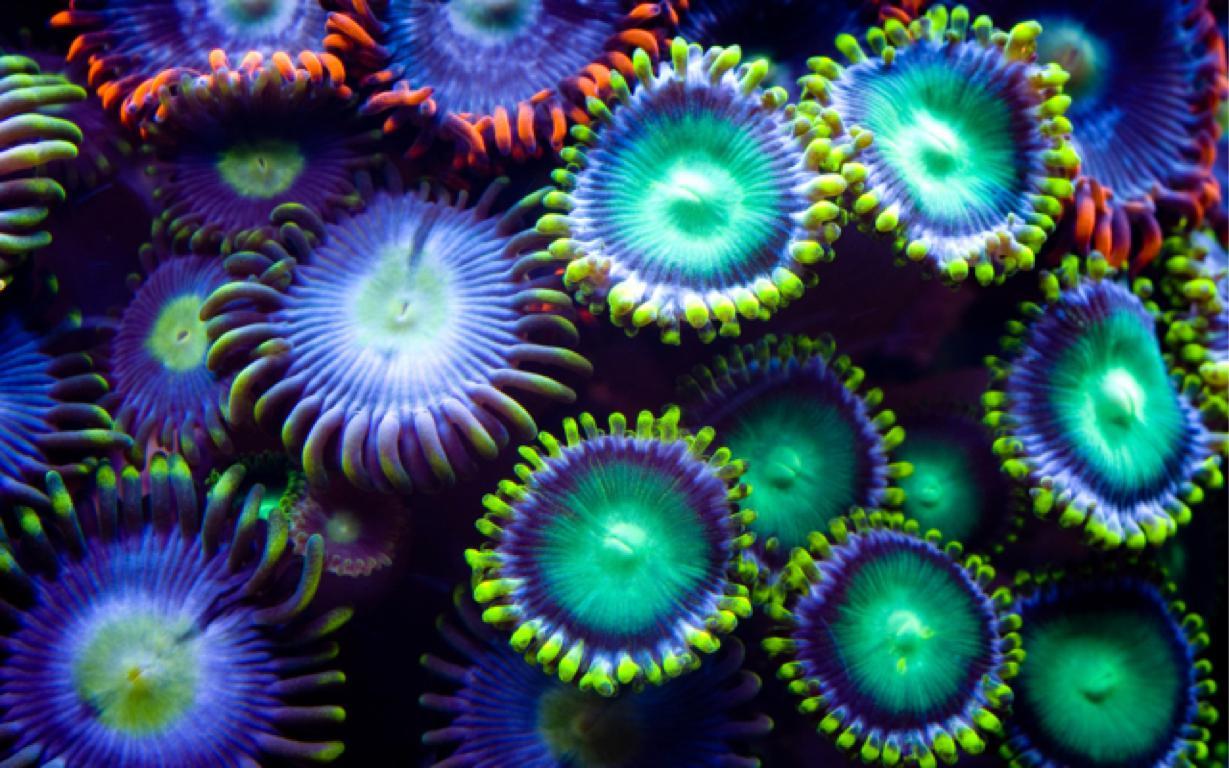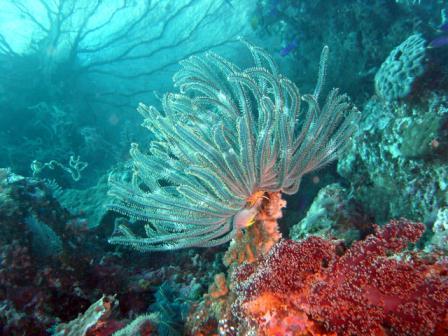The first image is the image on the left, the second image is the image on the right. Evaluate the accuracy of this statement regarding the images: "There is a clownfish somewhere in the pair.". Is it true? Answer yes or no. No. The first image is the image on the left, the second image is the image on the right. Given the left and right images, does the statement "One of the images shows exactly one orange and white fish next to an urchin." hold true? Answer yes or no. No. 